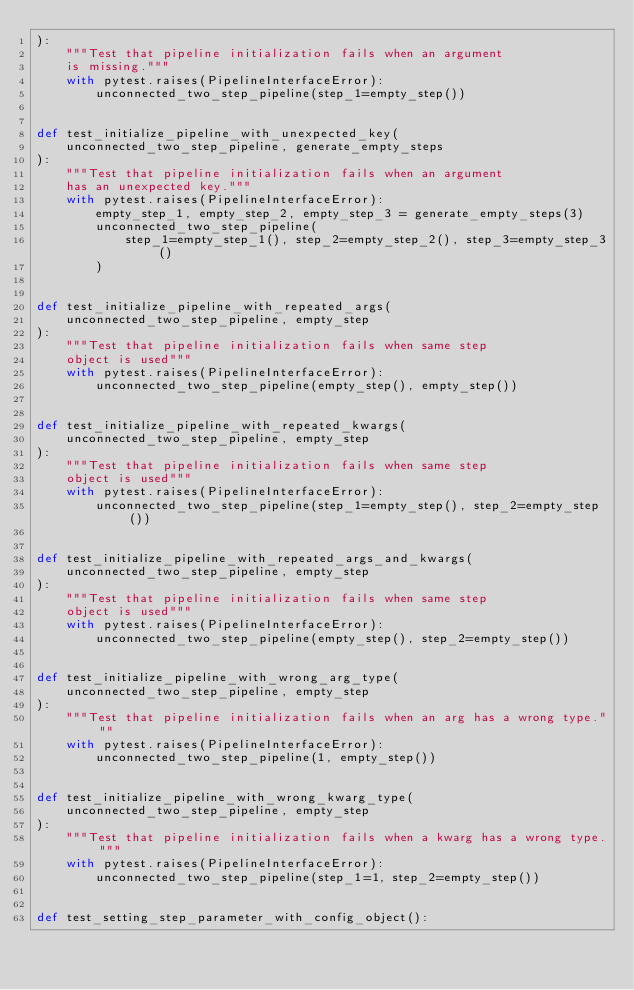Convert code to text. <code><loc_0><loc_0><loc_500><loc_500><_Python_>):
    """Test that pipeline initialization fails when an argument
    is missing."""
    with pytest.raises(PipelineInterfaceError):
        unconnected_two_step_pipeline(step_1=empty_step())


def test_initialize_pipeline_with_unexpected_key(
    unconnected_two_step_pipeline, generate_empty_steps
):
    """Test that pipeline initialization fails when an argument
    has an unexpected key."""
    with pytest.raises(PipelineInterfaceError):
        empty_step_1, empty_step_2, empty_step_3 = generate_empty_steps(3)
        unconnected_two_step_pipeline(
            step_1=empty_step_1(), step_2=empty_step_2(), step_3=empty_step_3()
        )


def test_initialize_pipeline_with_repeated_args(
    unconnected_two_step_pipeline, empty_step
):
    """Test that pipeline initialization fails when same step
    object is used"""
    with pytest.raises(PipelineInterfaceError):
        unconnected_two_step_pipeline(empty_step(), empty_step())


def test_initialize_pipeline_with_repeated_kwargs(
    unconnected_two_step_pipeline, empty_step
):
    """Test that pipeline initialization fails when same step
    object is used"""
    with pytest.raises(PipelineInterfaceError):
        unconnected_two_step_pipeline(step_1=empty_step(), step_2=empty_step())


def test_initialize_pipeline_with_repeated_args_and_kwargs(
    unconnected_two_step_pipeline, empty_step
):
    """Test that pipeline initialization fails when same step
    object is used"""
    with pytest.raises(PipelineInterfaceError):
        unconnected_two_step_pipeline(empty_step(), step_2=empty_step())


def test_initialize_pipeline_with_wrong_arg_type(
    unconnected_two_step_pipeline, empty_step
):
    """Test that pipeline initialization fails when an arg has a wrong type."""
    with pytest.raises(PipelineInterfaceError):
        unconnected_two_step_pipeline(1, empty_step())


def test_initialize_pipeline_with_wrong_kwarg_type(
    unconnected_two_step_pipeline, empty_step
):
    """Test that pipeline initialization fails when a kwarg has a wrong type."""
    with pytest.raises(PipelineInterfaceError):
        unconnected_two_step_pipeline(step_1=1, step_2=empty_step())


def test_setting_step_parameter_with_config_object():</code> 